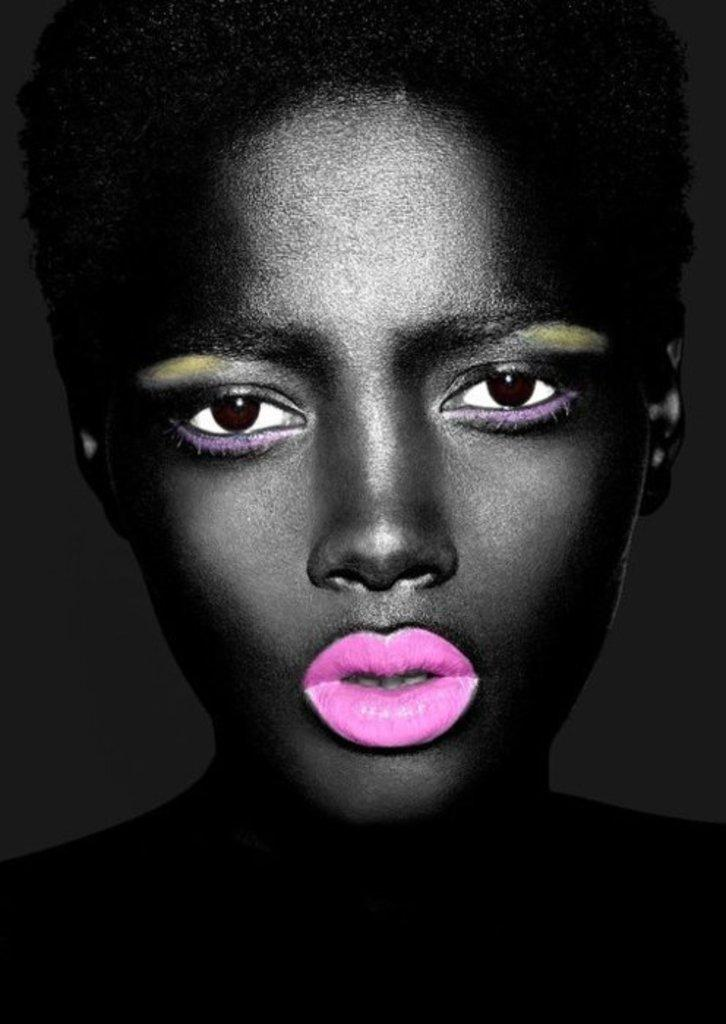What is the main subject of the image? There is a person in the image. Can you describe the person's appearance? The person is wearing pink lipstick. What is the color of the background in the image? The background of the image is black. Can you tell me how many mittens are visible in the image? There are no mittens present in the image. What type of corn is being grown in the background of the image? There is no corn visible in the image, and the background is black. 